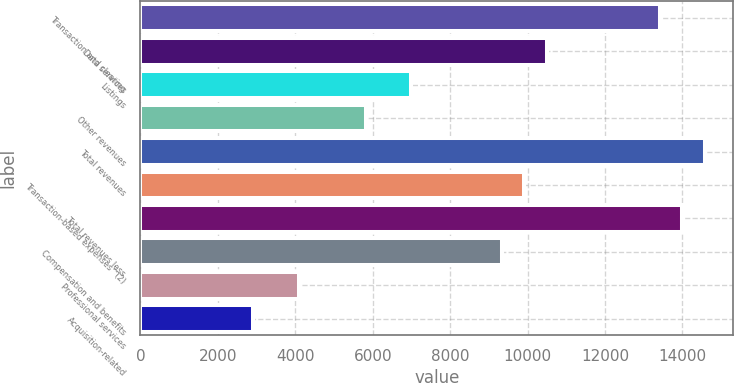Convert chart. <chart><loc_0><loc_0><loc_500><loc_500><bar_chart><fcel>Transaction and clearing<fcel>Data services<fcel>Listings<fcel>Other revenues<fcel>Total revenues<fcel>Transaction-based expenses^(2)<fcel>Total revenues less<fcel>Compensation and benefits<fcel>Professional services<fcel>Acquisition-related<nl><fcel>13417.2<fcel>10500.6<fcel>7000.64<fcel>5834<fcel>14583.8<fcel>9917.24<fcel>14000.5<fcel>9333.92<fcel>4084.04<fcel>2917.4<nl></chart> 